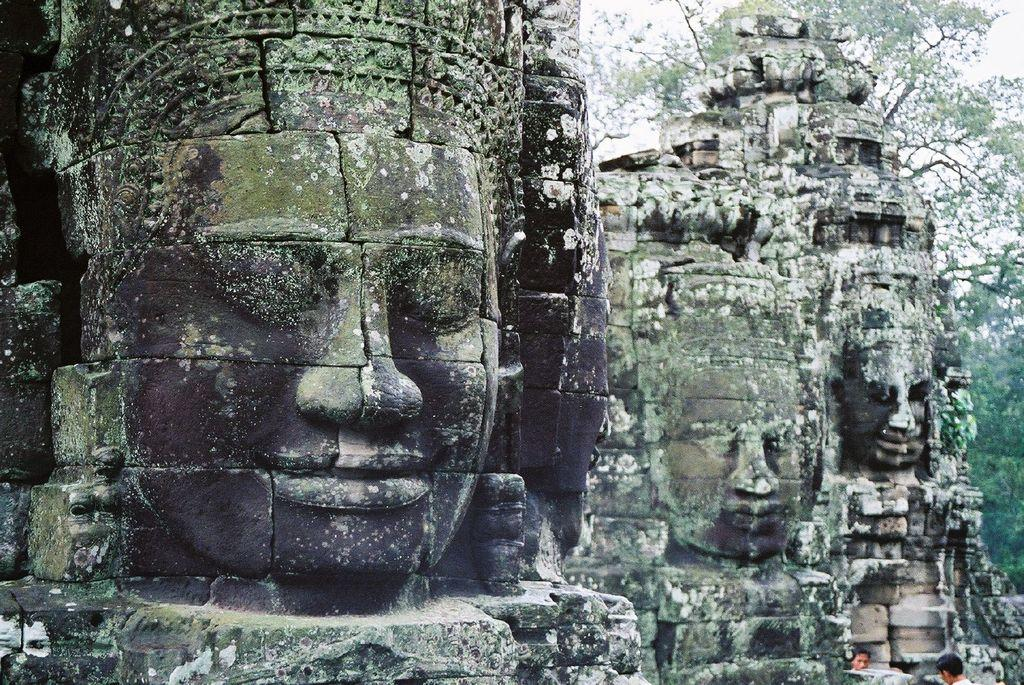What type of artwork can be seen in the image? There are sculptures in the image. Are there any people present in the image? Yes, there are persons in the image. What type of natural elements can be seen in the image? There are trees in the image. How many horses are present in the image? There are no horses present in the image. What process is being depicted in the image? The image does not depict a specific process; it features sculptures, persons, and trees. 